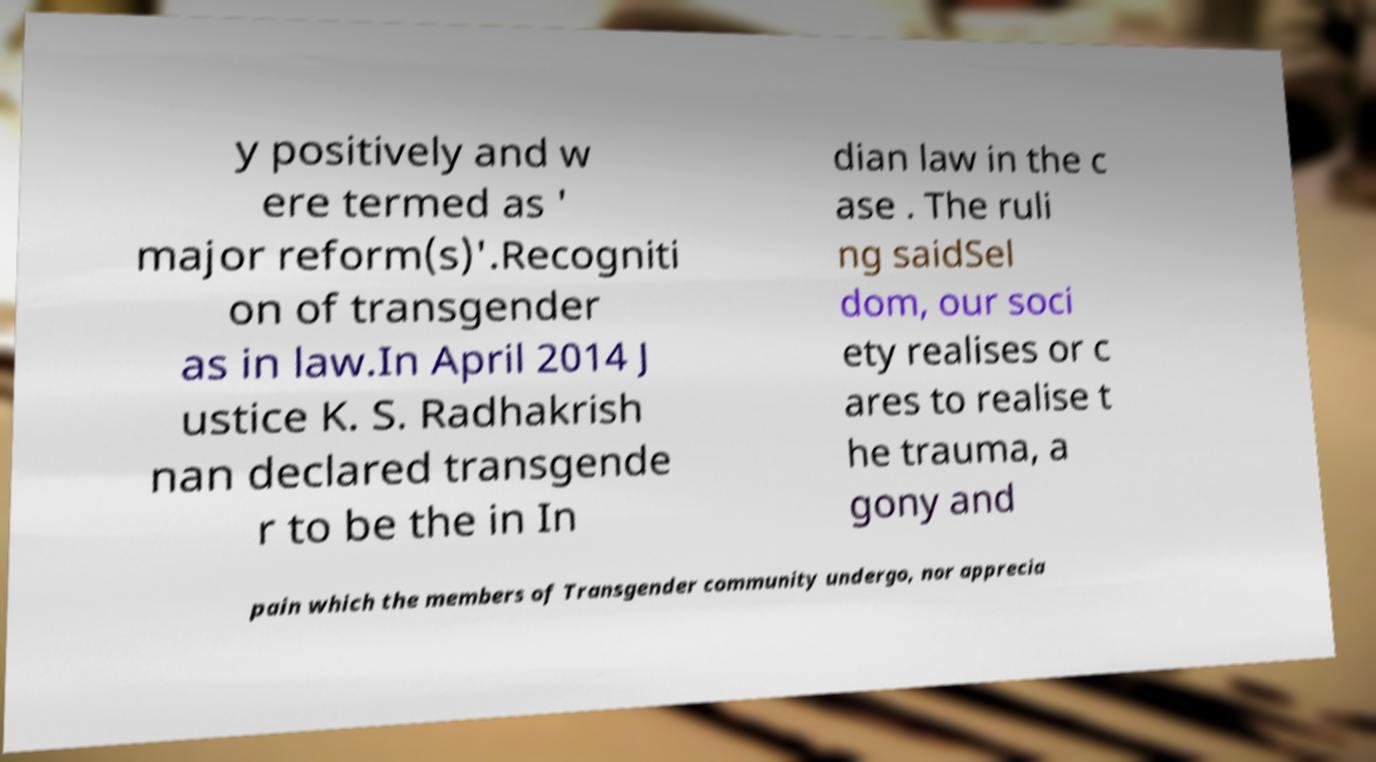What messages or text are displayed in this image? I need them in a readable, typed format. y positively and w ere termed as ' major reform(s)'.Recogniti on of transgender as in law.In April 2014 J ustice K. S. Radhakrish nan declared transgende r to be the in In dian law in the c ase . The ruli ng saidSel dom, our soci ety realises or c ares to realise t he trauma, a gony and pain which the members of Transgender community undergo, nor apprecia 